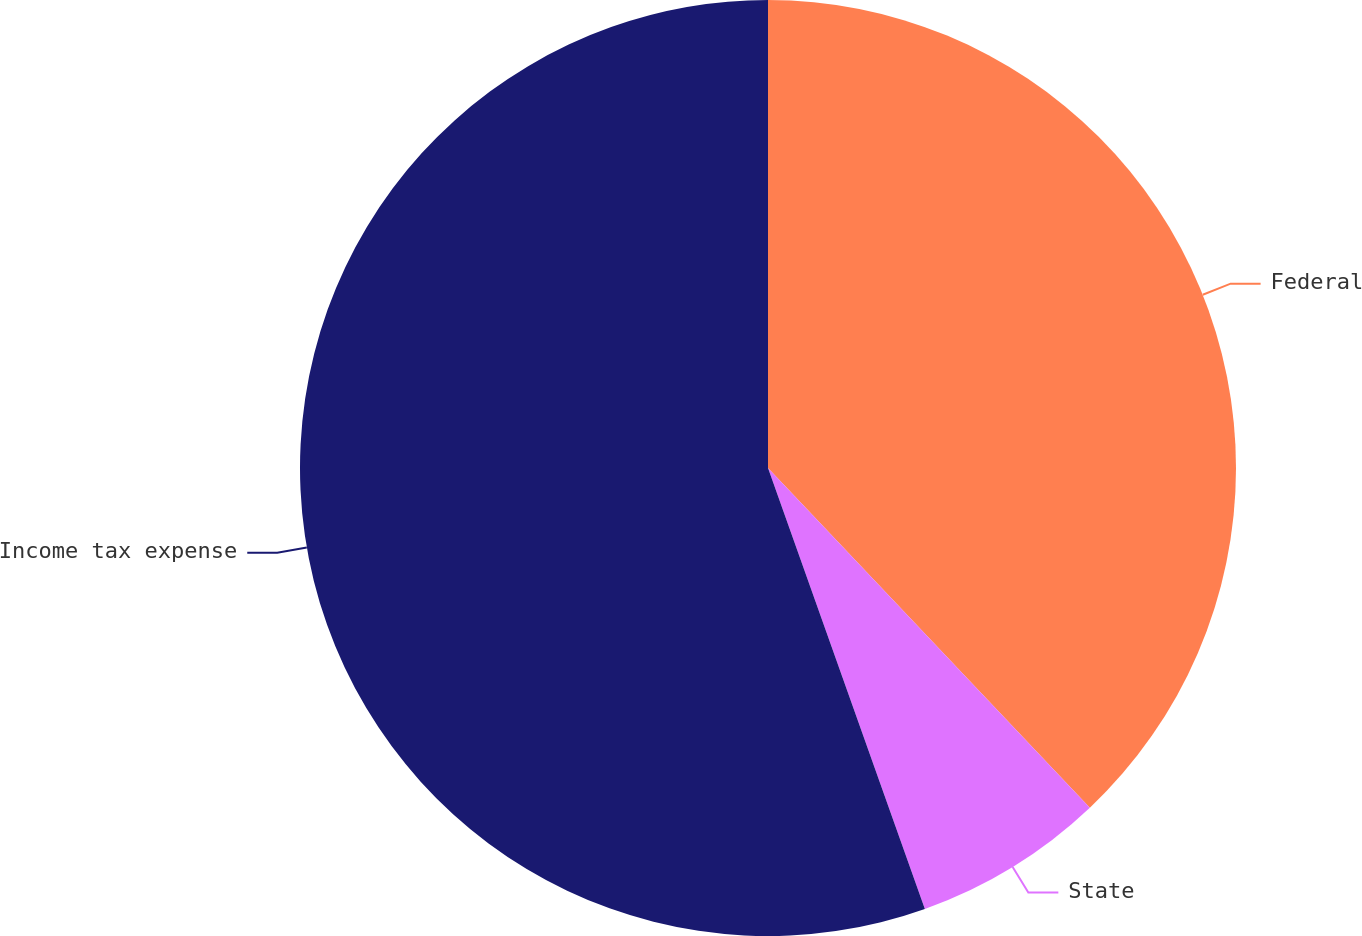Convert chart to OTSL. <chart><loc_0><loc_0><loc_500><loc_500><pie_chart><fcel>Federal<fcel>State<fcel>Income tax expense<nl><fcel>37.93%<fcel>6.63%<fcel>55.44%<nl></chart> 